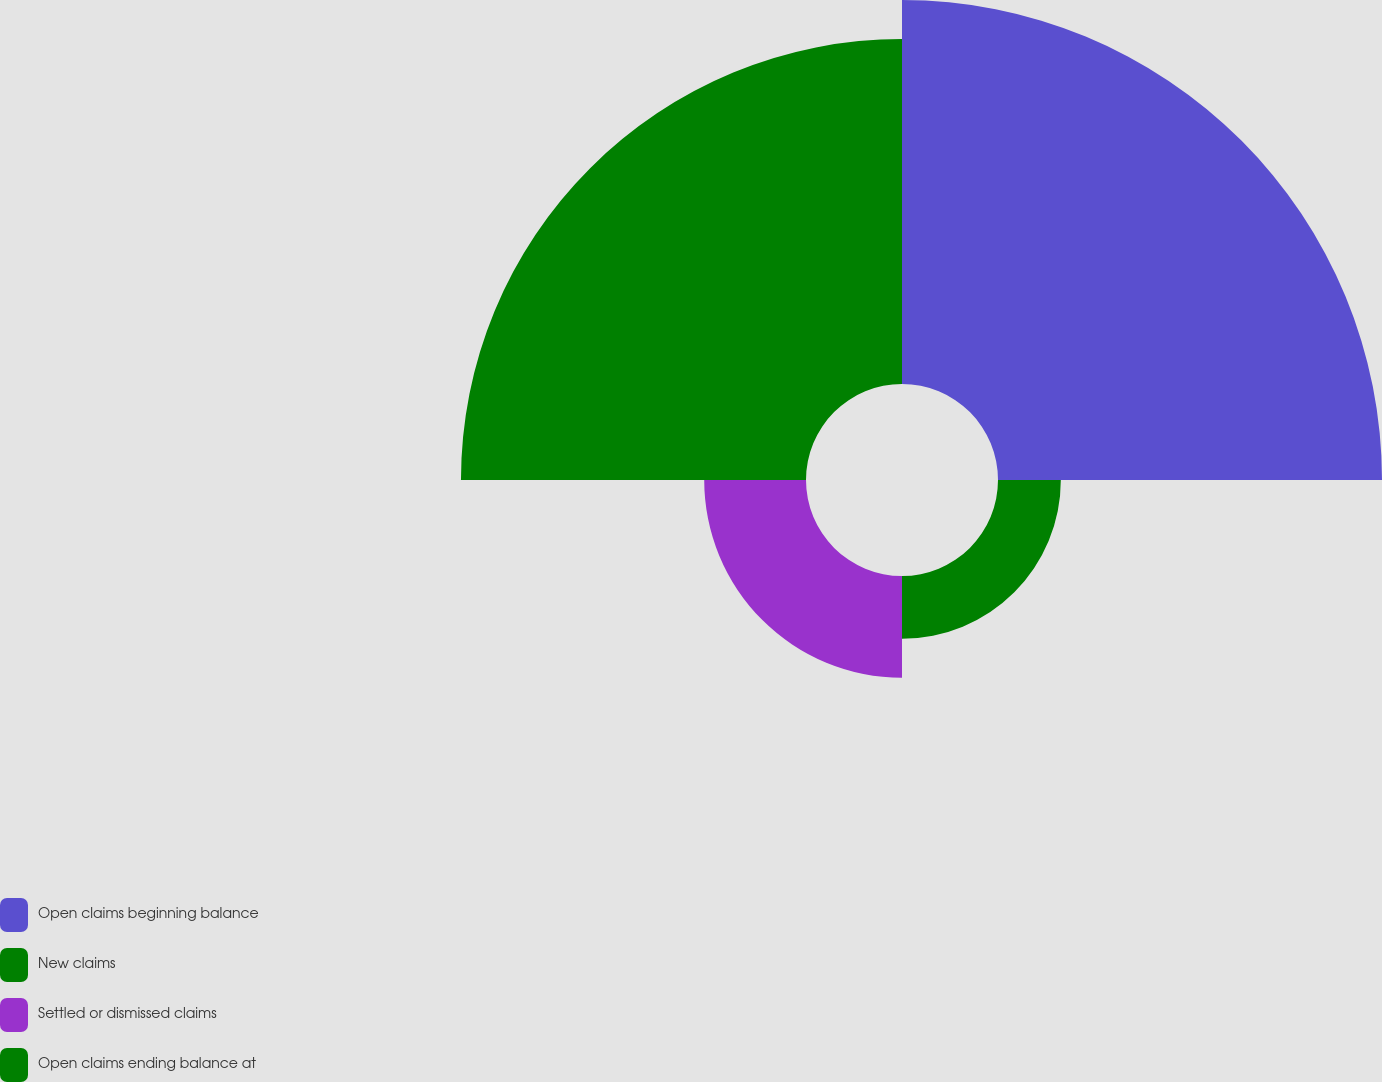Convert chart. <chart><loc_0><loc_0><loc_500><loc_500><pie_chart><fcel>Open claims beginning balance<fcel>New claims<fcel>Settled or dismissed claims<fcel>Open claims ending balance at<nl><fcel>42.97%<fcel>7.03%<fcel>11.39%<fcel>38.61%<nl></chart> 